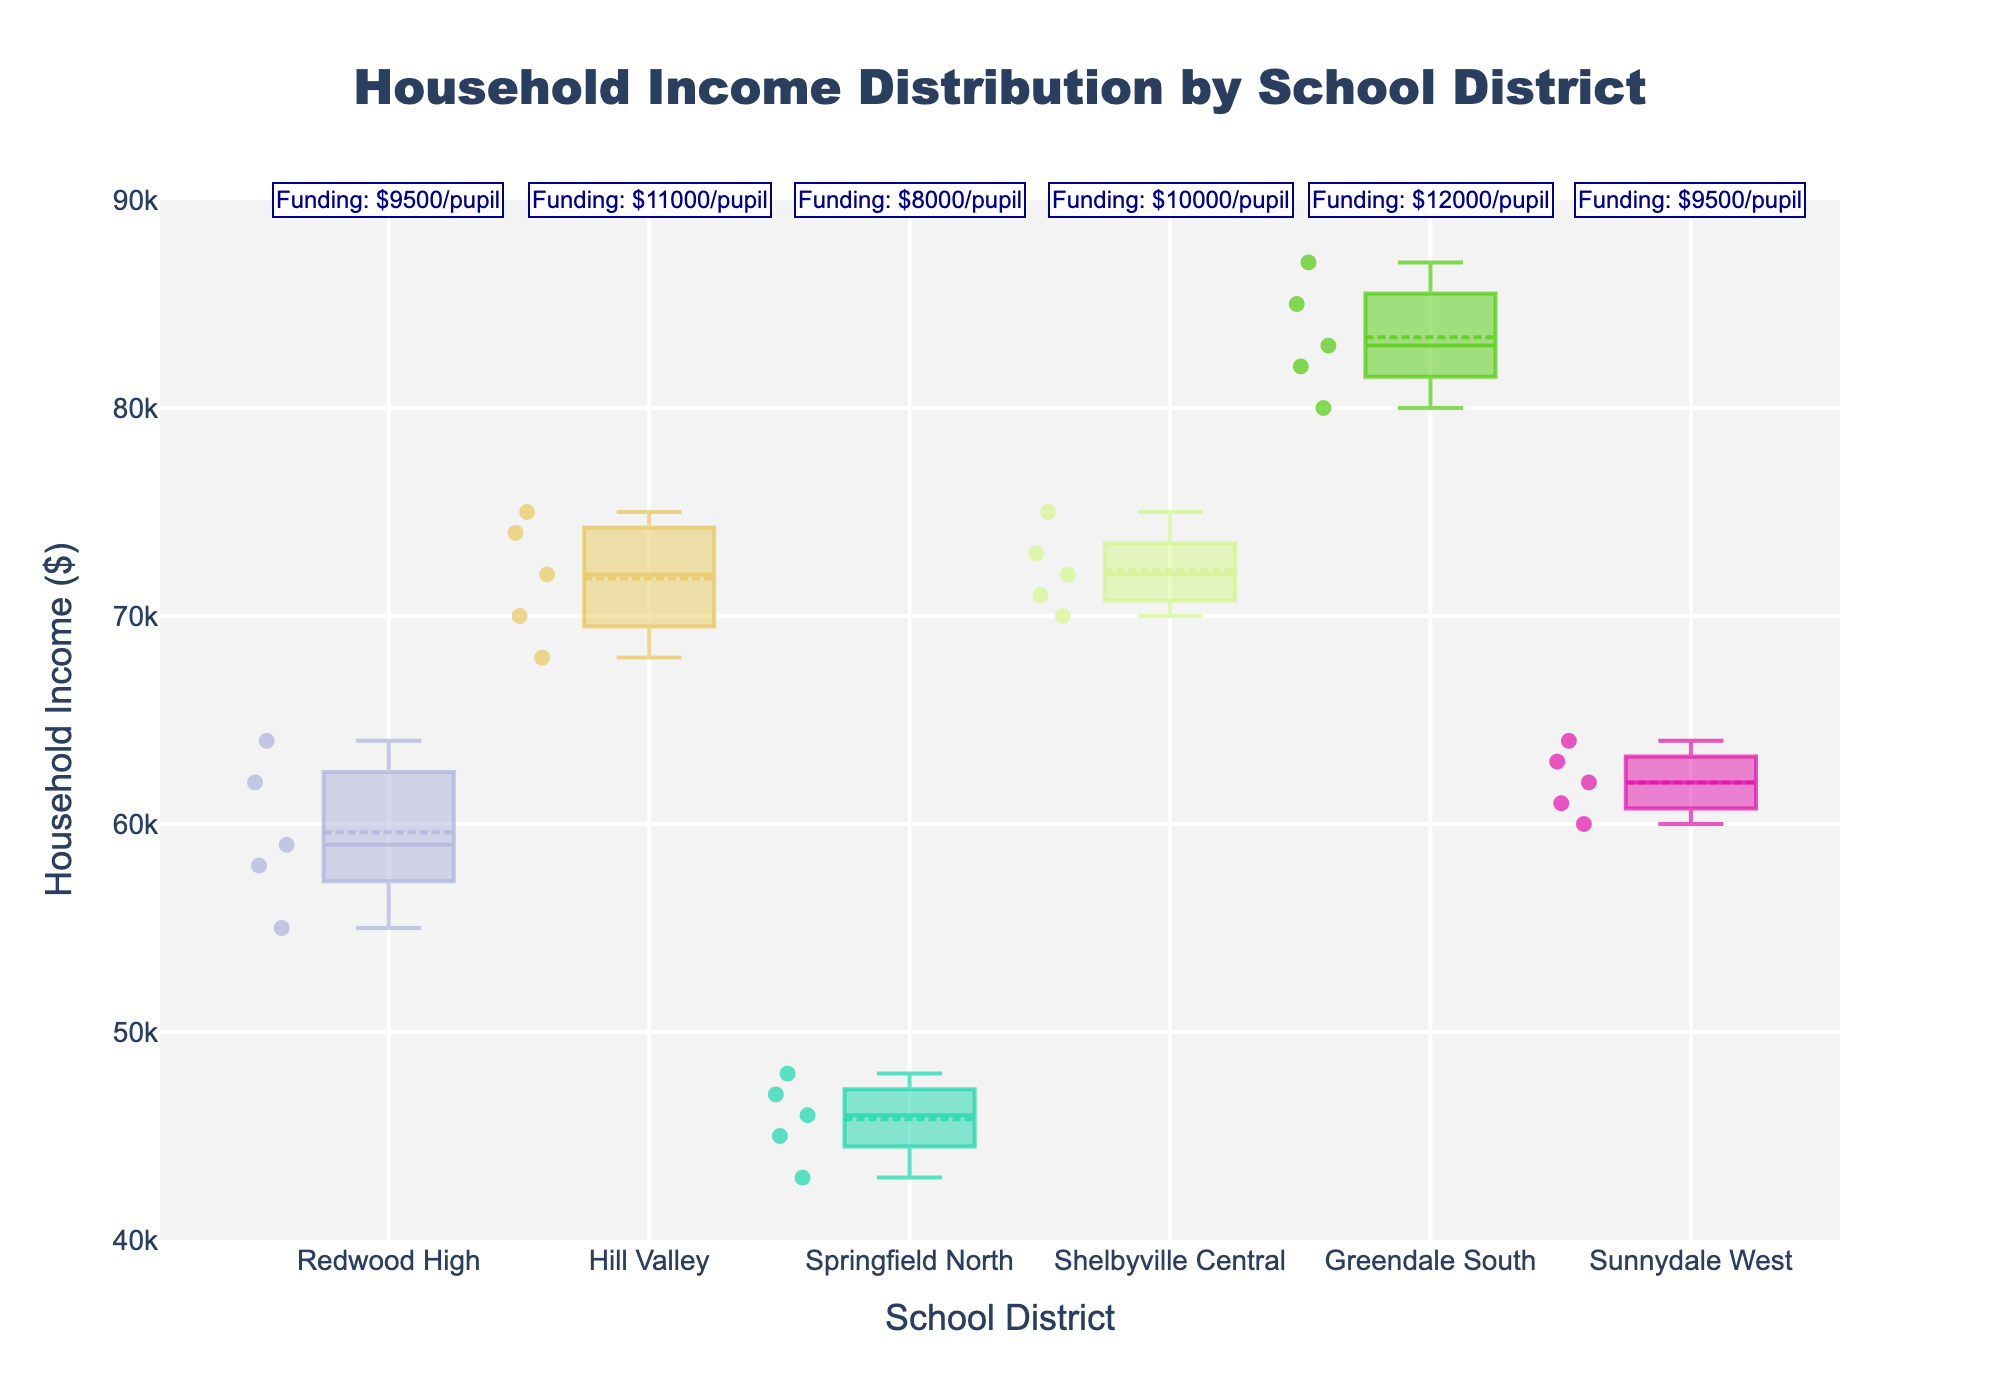what is the title of the figure? The title of the figure is prominently displayed at the top of the plot. By visually inspecting this area, we can read the title.
Answer: Household Income Distribution by School District how many school districts are presented in the plot? By counting the unique box plots on the x-axis, each representing a school district, we can determine the total number of school districts shown.
Answer: 6 which school district has the widest box plot? The width of the box plots varies based on the number of data points. The district with the most data points will have the widest box plot.
Answer: Redwood High (tie with Sunnydale West) what's the median household income for Redwood High? Each box plot shows a line in the middle, which represents the median value. By inspecting Redwood High's box plot, we can find this median line and read the corresponding income value.
Answer: 59000 which school district received the highest educational funding per pupil? According to the annotations above each box plot which indicates educational funding, we look for the highest annotated value.
Answer: Greendale South ($12000/pupil) which school district has the smallest interquartile range (IQR) in household income? The IQR is represented by the length of the box (from the first quartile to the third quartile). By visually comparing the lengths of these boxes across school districts, we identify the smallest.
Answer: Springfield North how does the median household income in Hill Valley compare to Shelbyville Central? We observe the median lines in the box plots of both Hill Valley and Shelbyville Central and compare their values directly.
Answer: Hill Valley's median is slightly higher than Shelbyville Central which school district has the highest median household income? By inspecting the median lines across all box plots and identifying the highest, we can determine this.
Answer: Greendale South how do household incomes in Sunnydale West compare to those in Redwood High? We analyze the box plots for Sunnydale West and Redwood High, inspecting their medians, ranges, and distributions of data points to compare incomes.
Answer: Sunnydale West has slightly higher incomes but the distributions largely overlap based on the plot, does higher educational funding correlate with higher household income? We look at the educational funding annotations and compare them with the median household incomes shown by the box plots to identify any trends or correlations.
Answer: Yes, generally higher funding correlates with higher household income 